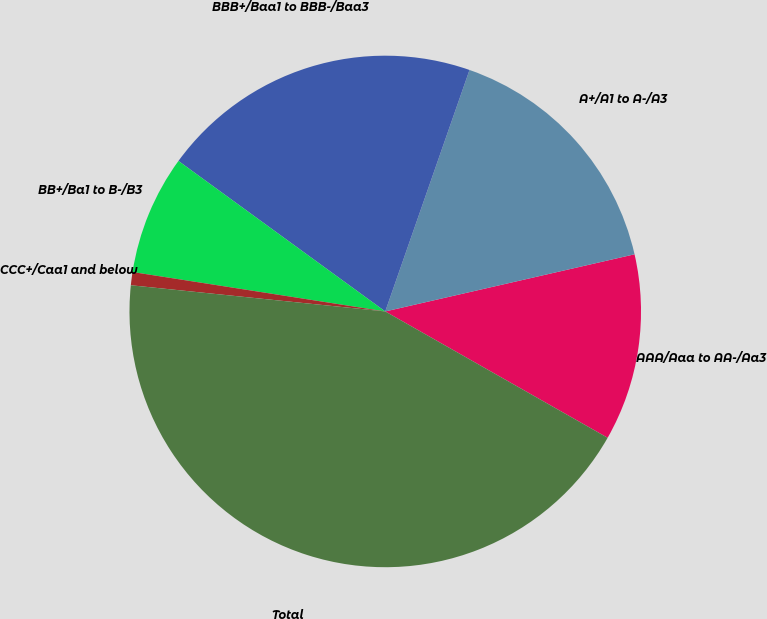Convert chart. <chart><loc_0><loc_0><loc_500><loc_500><pie_chart><fcel>AAA/Aaa to AA-/Aa3<fcel>A+/A1 to A-/A3<fcel>BBB+/Baa1 to BBB-/Baa3<fcel>BB+/Ba1 to B-/B3<fcel>CCC+/Caa1 and below<fcel>Total<nl><fcel>11.81%<fcel>16.07%<fcel>20.33%<fcel>7.55%<fcel>0.83%<fcel>43.41%<nl></chart> 